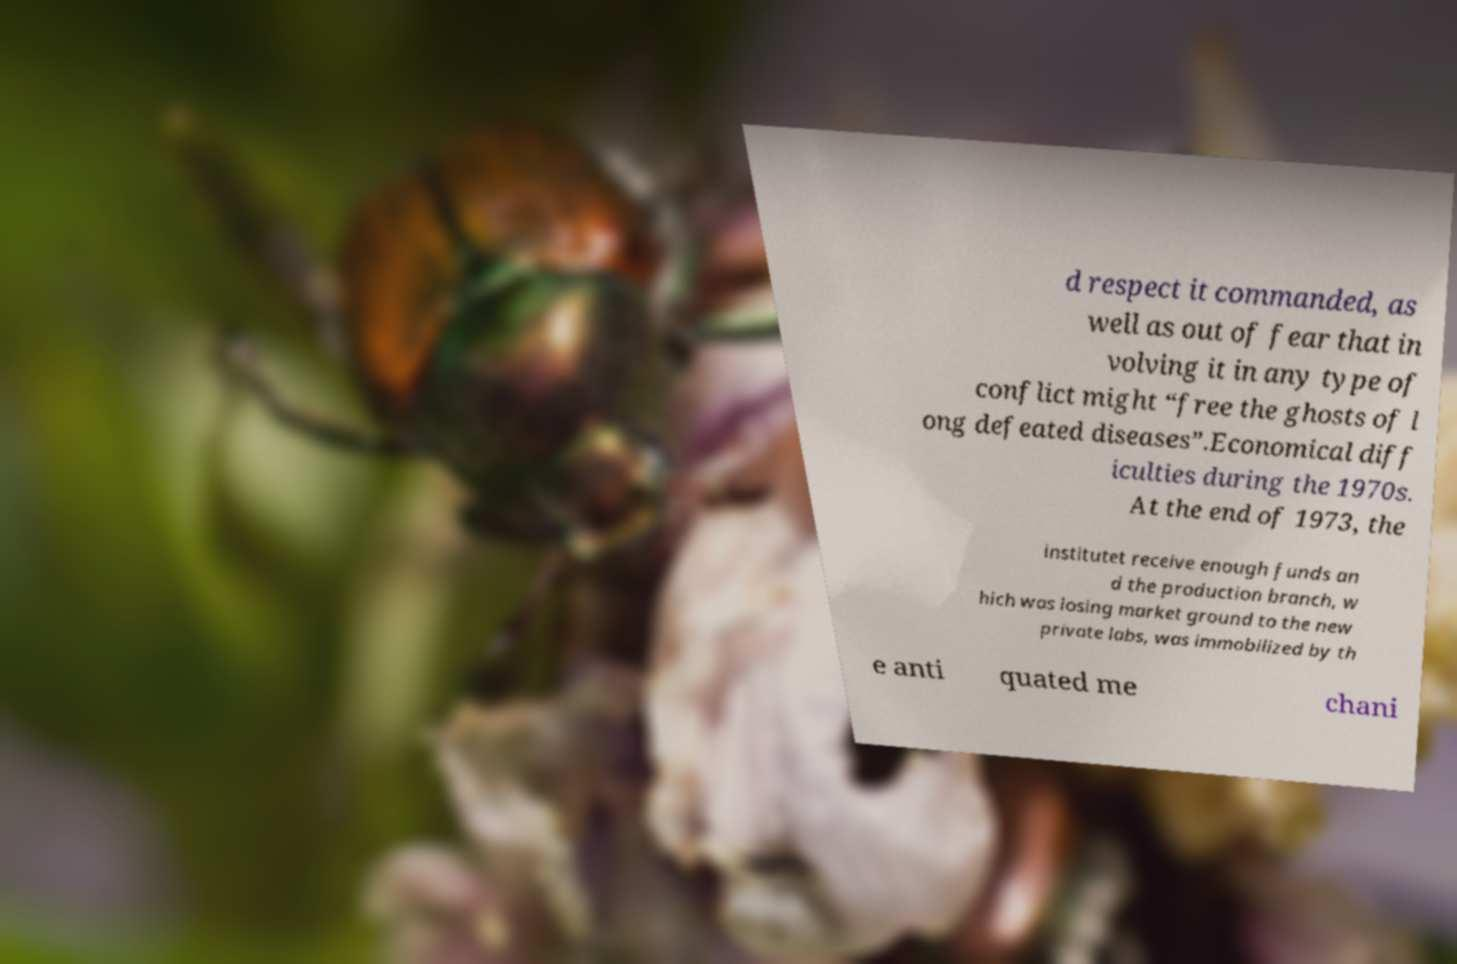Could you assist in decoding the text presented in this image and type it out clearly? d respect it commanded, as well as out of fear that in volving it in any type of conflict might “free the ghosts of l ong defeated diseases”.Economical diff iculties during the 1970s. At the end of 1973, the institutet receive enough funds an d the production branch, w hich was losing market ground to the new private labs, was immobilized by th e anti quated me chani 